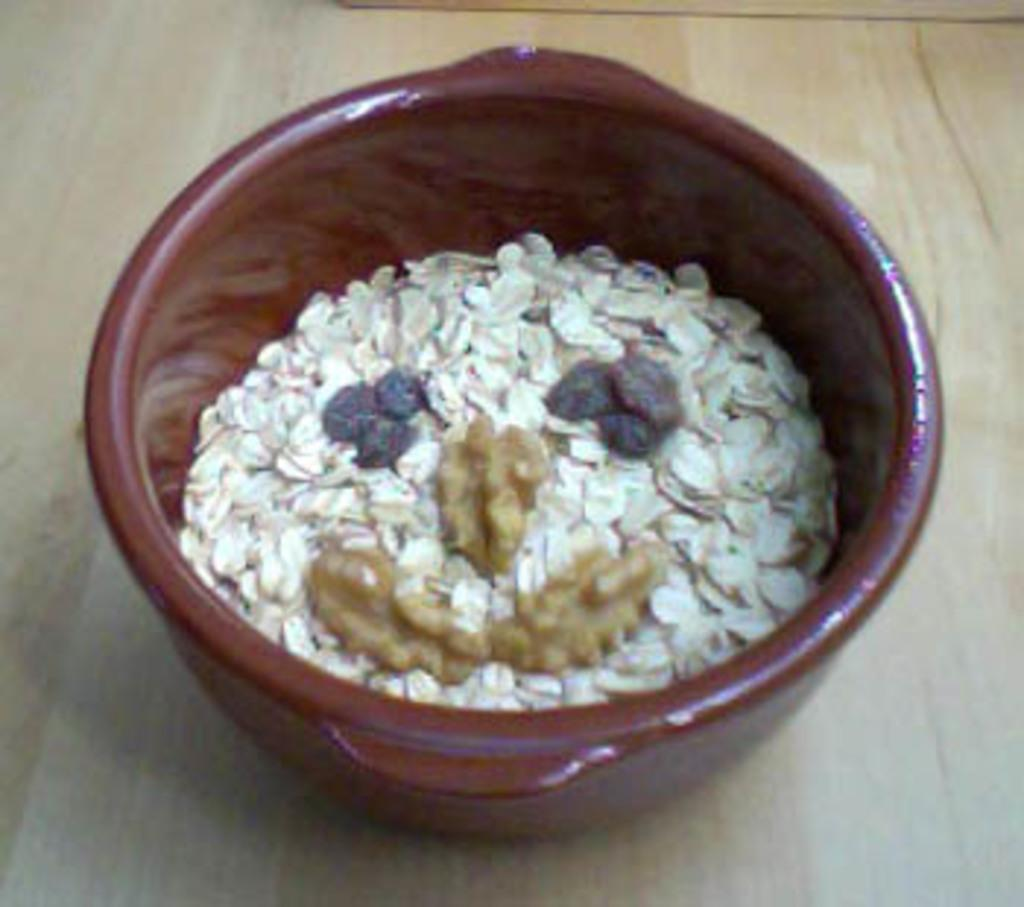What is located in the center of the image? There is a bowl in the center of the image. What is inside the bowl? The bowl contains oats and dry fruits. What type of land can be seen in the image? There is no land visible in the image; it only features a bowl with oats and dry fruits. 